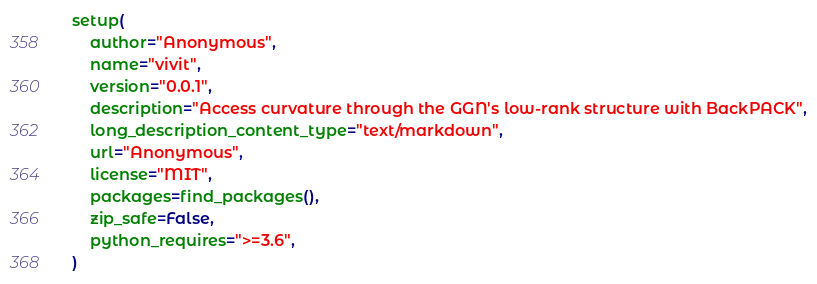Convert code to text. <code><loc_0><loc_0><loc_500><loc_500><_Python_>
setup(
    author="Anonymous",
    name="vivit",
    version="0.0.1",
    description="Access curvature through the GGN's low-rank structure with BackPACK",
    long_description_content_type="text/markdown",
    url="Anonymous",
    license="MIT",
    packages=find_packages(),
    zip_safe=False,
    python_requires=">=3.6",
)
</code> 